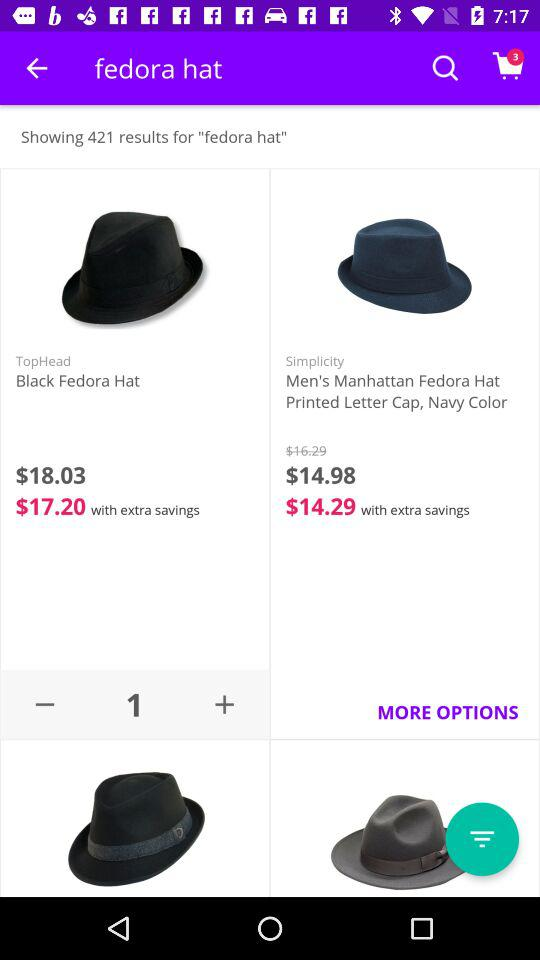How many items are in the shopping cart? There are 3 items in the shopping cart. 